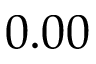<formula> <loc_0><loc_0><loc_500><loc_500>0 . 0 0</formula> 